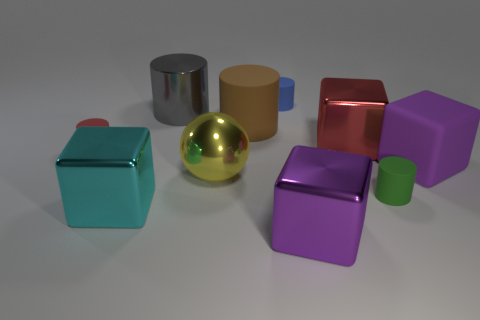What is the material of the big gray object that is the same shape as the green object?
Offer a terse response. Metal. There is a big metallic object to the left of the metallic cylinder; what shape is it?
Offer a very short reply. Cube. Is there a tiny yellow cylinder that has the same material as the big brown object?
Provide a short and direct response. No. Do the yellow metal object and the red rubber cylinder have the same size?
Keep it short and to the point. No. What number of cubes are green things or large shiny things?
Ensure brevity in your answer.  3. There is another large block that is the same color as the big matte block; what material is it?
Your response must be concise. Metal. What number of large red shiny objects are the same shape as the purple shiny thing?
Your answer should be very brief. 1. Is the number of yellow balls right of the big metallic ball greater than the number of small matte cylinders to the right of the big gray object?
Provide a succinct answer. No. There is a large cube that is in front of the cyan metallic object; is its color the same as the metallic sphere?
Offer a terse response. No. The blue matte cylinder has what size?
Offer a terse response. Small. 